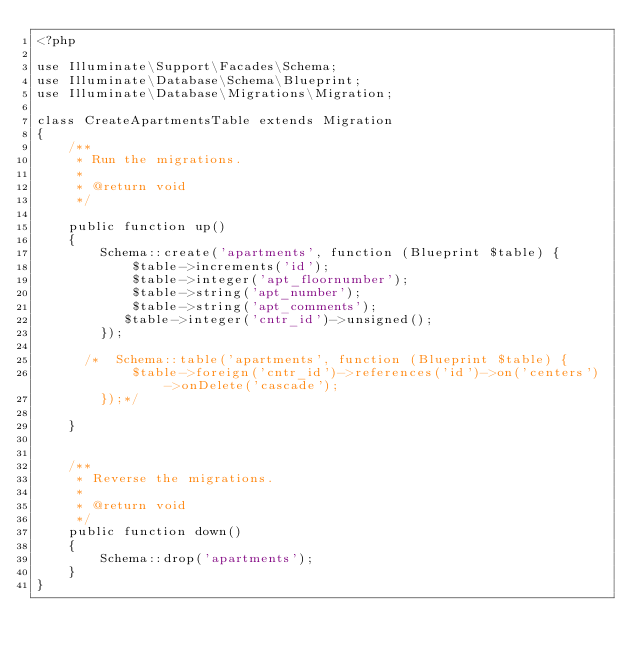<code> <loc_0><loc_0><loc_500><loc_500><_PHP_><?php

use Illuminate\Support\Facades\Schema;
use Illuminate\Database\Schema\Blueprint;
use Illuminate\Database\Migrations\Migration;

class CreateApartmentsTable extends Migration
{
    /**
     * Run the migrations.
     *
     * @return void
     */

    public function up()
    {
        Schema::create('apartments', function (Blueprint $table) {
            $table->increments('id');
            $table->integer('apt_floornumber');
            $table->string('apt_number');
            $table->string('apt_comments');
           $table->integer('cntr_id')->unsigned();
        });

      /*  Schema::table('apartments', function (Blueprint $table) {
            $table->foreign('cntr_id')->references('id')->on('centers')->onDelete('cascade');
        });*/

    }


    /**
     * Reverse the migrations.
     *
     * @return void
     */
    public function down()
    {
        Schema::drop('apartments');
    }
}
</code> 